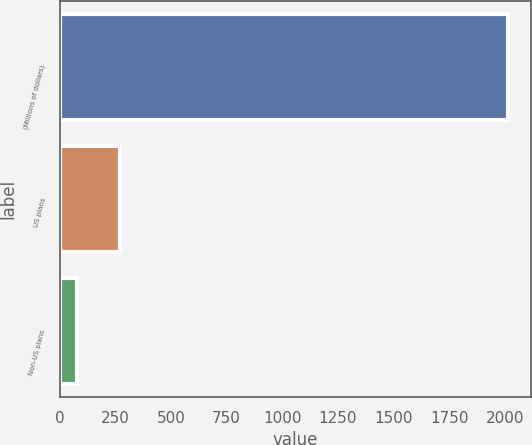Convert chart. <chart><loc_0><loc_0><loc_500><loc_500><bar_chart><fcel>(Millions of dollars)<fcel>US plans<fcel>Non-US plans<nl><fcel>2015<fcel>269.9<fcel>76<nl></chart> 